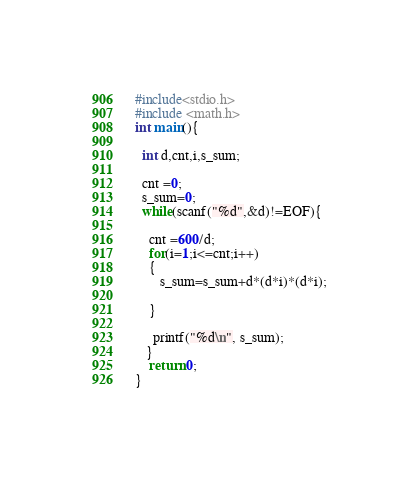Convert code to text. <code><loc_0><loc_0><loc_500><loc_500><_C_>#include<stdio.h>
#include <math.h>   
int main(){
 
  int d,cnt,i,s_sum;
  
  cnt =0;
  s_sum=0;
  while(scanf("%d",&d)!=EOF){

    cnt =600/d;        
    for(i=1;i<=cnt;i++)
    {
       s_sum=s_sum+d*(d*i)*(d*i);

    }
    
     printf("%d\n", s_sum);
   }   
    return 0;
}</code> 